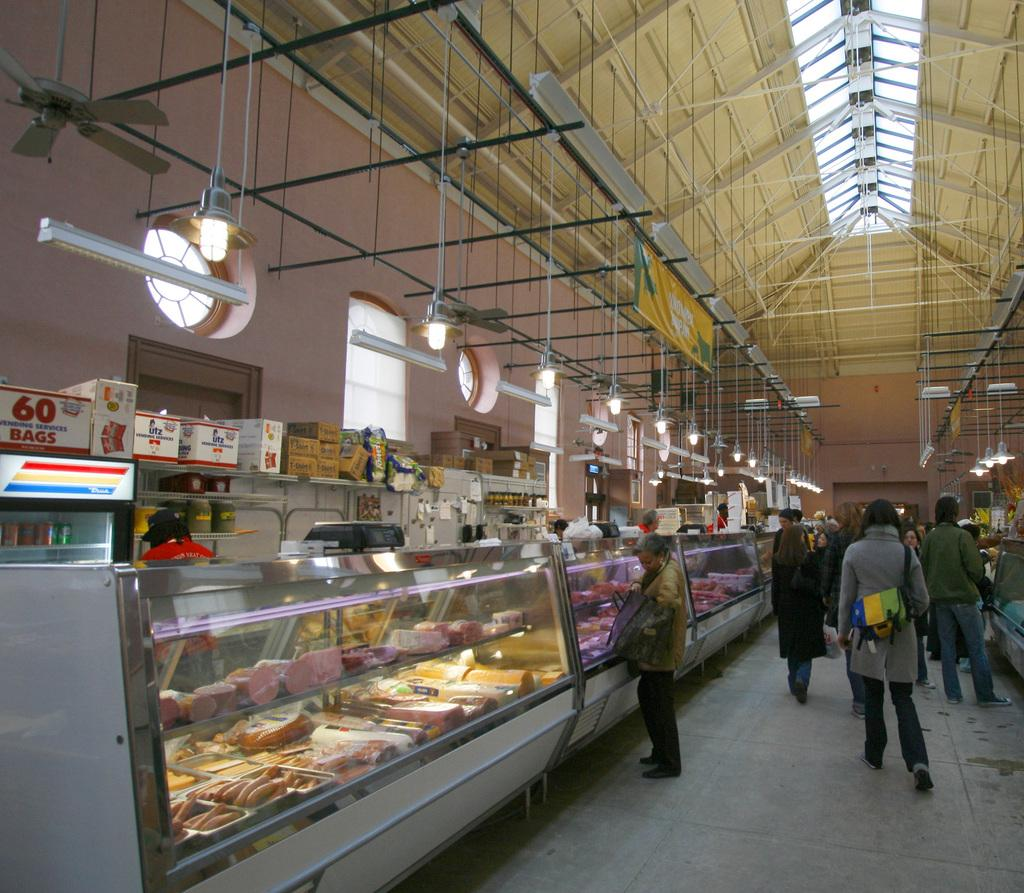<image>
Give a short and clear explanation of the subsequent image. A box of 60 bags is behind the deli counter at a shopping center. 